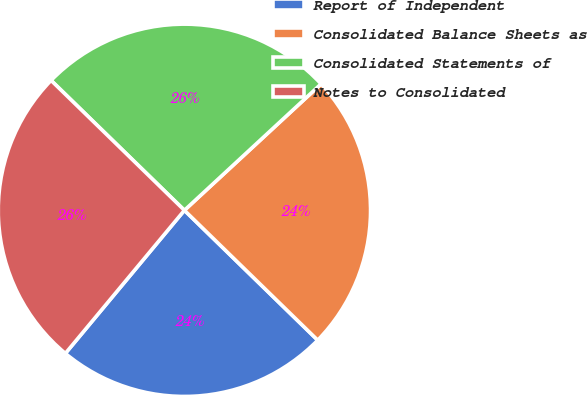<chart> <loc_0><loc_0><loc_500><loc_500><pie_chart><fcel>Report of Independent<fcel>Consolidated Balance Sheets as<fcel>Consolidated Statements of<fcel>Notes to Consolidated<nl><fcel>23.75%<fcel>24.17%<fcel>25.83%<fcel>26.25%<nl></chart> 